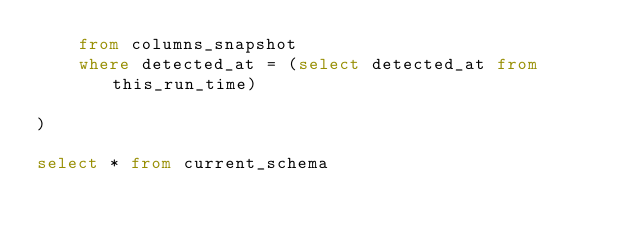<code> <loc_0><loc_0><loc_500><loc_500><_SQL_>    from columns_snapshot
    where detected_at = (select detected_at from this_run_time)

)

select * from current_schema

</code> 